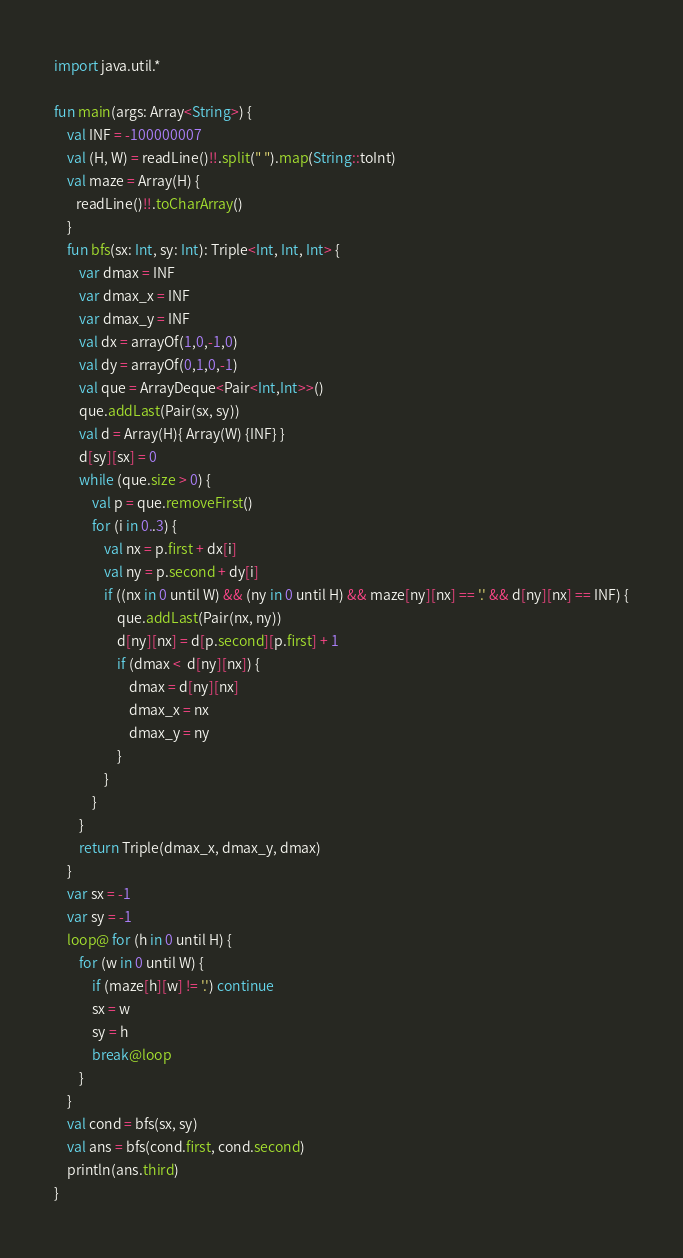Convert code to text. <code><loc_0><loc_0><loc_500><loc_500><_Kotlin_>import java.util.*

fun main(args: Array<String>) {
    val INF = -100000007
    val (H, W) = readLine()!!.split(" ").map(String::toInt)
    val maze = Array(H) {
       readLine()!!.toCharArray()
    }
    fun bfs(sx: Int, sy: Int): Triple<Int, Int, Int> {
        var dmax = INF
        var dmax_x = INF
        var dmax_y = INF
        val dx = arrayOf(1,0,-1,0)
        val dy = arrayOf(0,1,0,-1)
        val que = ArrayDeque<Pair<Int,Int>>()
        que.addLast(Pair(sx, sy))
        val d = Array(H){ Array(W) {INF} }
        d[sy][sx] = 0
        while (que.size > 0) {
            val p = que.removeFirst()
            for (i in 0..3) {
                val nx = p.first + dx[i]
                val ny = p.second + dy[i]
                if ((nx in 0 until W) && (ny in 0 until H) && maze[ny][nx] == '.' && d[ny][nx] == INF) {
                    que.addLast(Pair(nx, ny))
                    d[ny][nx] = d[p.second][p.first] + 1
                    if (dmax <  d[ny][nx]) {
                        dmax = d[ny][nx]
                        dmax_x = nx
                        dmax_y = ny
                    }
                }
            }
        }
        return Triple(dmax_x, dmax_y, dmax)
    }
    var sx = -1
    var sy = -1
    loop@ for (h in 0 until H) {
        for (w in 0 until W) {
            if (maze[h][w] != '.') continue
            sx = w
            sy = h
            break@loop
        }
    }
    val cond = bfs(sx, sy)
    val ans = bfs(cond.first, cond.second)
    println(ans.third)
}</code> 